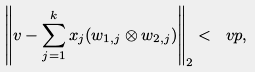<formula> <loc_0><loc_0><loc_500><loc_500>\left \| v - \sum _ { j = 1 } ^ { k } x _ { j } ( w _ { 1 , j } \otimes w _ { 2 , j } ) \right \| _ { 2 } < \ v p ,</formula> 